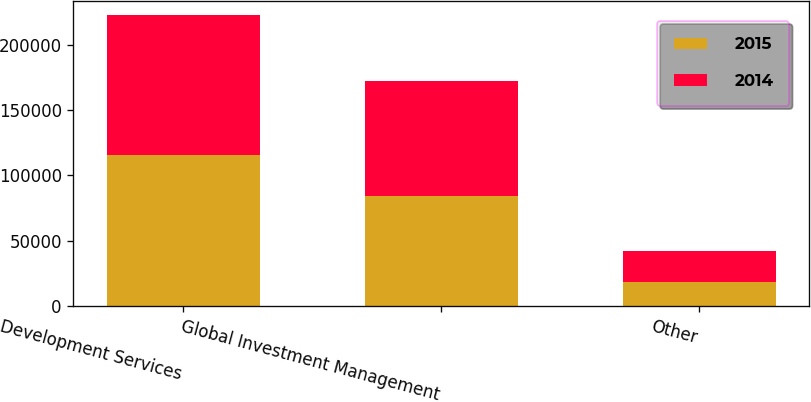<chart> <loc_0><loc_0><loc_500><loc_500><stacked_bar_chart><ecel><fcel>Development Services<fcel>Global Investment Management<fcel>Other<nl><fcel>2015<fcel>115326<fcel>84534<fcel>18083<nl><fcel>2014<fcel>107188<fcel>87352<fcel>23740<nl></chart> 